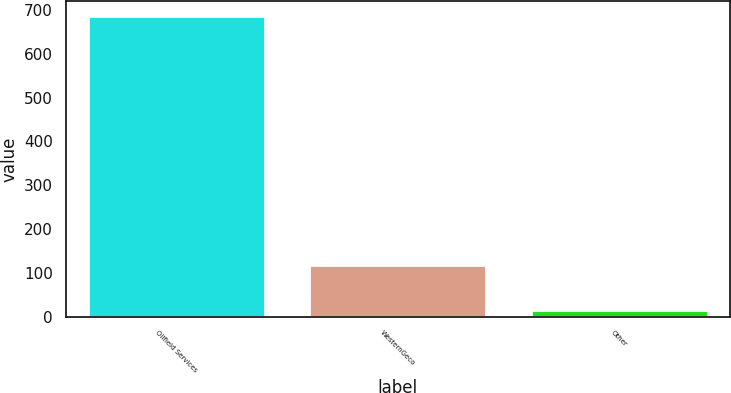Convert chart to OTSL. <chart><loc_0><loc_0><loc_500><loc_500><bar_chart><fcel>Oilfield Services<fcel>WesternGeco<fcel>Other<nl><fcel>686<fcel>118<fcel>15<nl></chart> 